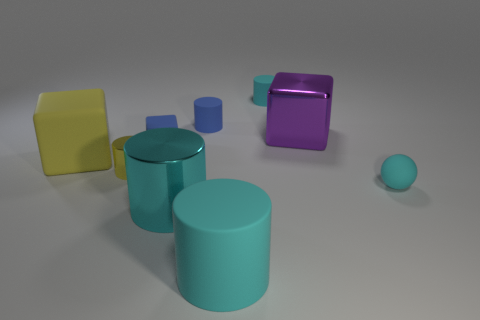Subtract all green balls. How many cyan cylinders are left? 3 Subtract all yellow cylinders. How many cylinders are left? 4 Subtract all blue cylinders. How many cylinders are left? 4 Subtract 2 cylinders. How many cylinders are left? 3 Subtract all green cylinders. Subtract all gray spheres. How many cylinders are left? 5 Subtract all cubes. How many objects are left? 6 Add 5 large cyan metal objects. How many large cyan metal objects exist? 6 Subtract 1 yellow cubes. How many objects are left? 8 Subtract all yellow blocks. Subtract all tiny yellow cylinders. How many objects are left? 7 Add 7 cyan shiny cylinders. How many cyan shiny cylinders are left? 8 